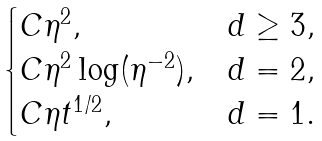<formula> <loc_0><loc_0><loc_500><loc_500>\begin{cases} C \eta ^ { 2 } , & d \geq 3 , \\ C \eta ^ { 2 } \log ( \eta ^ { - 2 } ) , & d = 2 , \\ C \eta t ^ { 1 / 2 } , & d = 1 . \end{cases}</formula> 